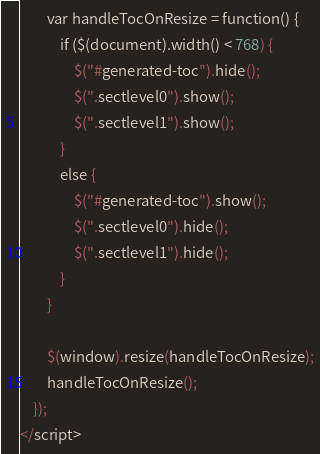<code> <loc_0><loc_0><loc_500><loc_500><_HTML_>        var handleTocOnResize = function() {
            if ($(document).width() < 768) {
                $("#generated-toc").hide();
                $(".sectlevel0").show();
                $(".sectlevel1").show();
            }
            else {
                $("#generated-toc").show();
                $(".sectlevel0").hide();
                $(".sectlevel1").hide();
            }
        }

        $(window).resize(handleTocOnResize);
        handleTocOnResize();
    });
</script></code> 